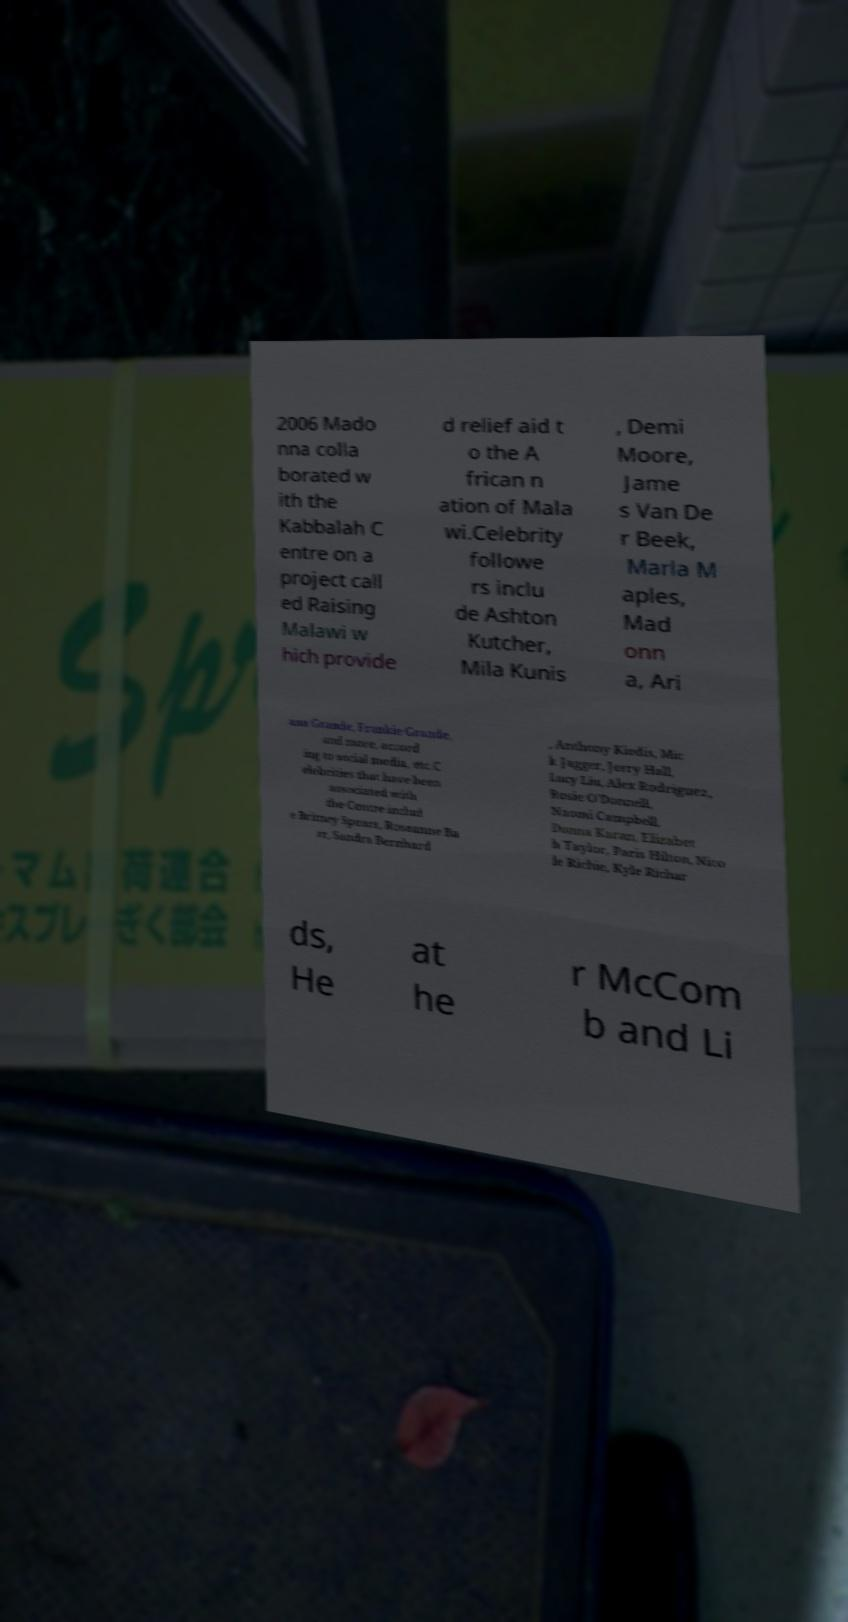Could you assist in decoding the text presented in this image and type it out clearly? 2006 Mado nna colla borated w ith the Kabbalah C entre on a project call ed Raising Malawi w hich provide d relief aid t o the A frican n ation of Mala wi.Celebrity followe rs inclu de Ashton Kutcher, Mila Kunis , Demi Moore, Jame s Van De r Beek, Marla M aples, Mad onn a, Ari ana Grande, Frankie Grande, and more, accord ing to social media, etc.C elebrities that have been associated with the Centre includ e Britney Spears, Roseanne Ba rr, Sandra Bernhard , Anthony Kiedis, Mic k Jagger, Jerry Hall, Lucy Liu, Alex Rodriguez, Rosie O'Donnell, Naomi Campbell, Donna Karan, Elizabet h Taylor, Paris Hilton, Nico le Richie, Kyle Richar ds, He at he r McCom b and Li 